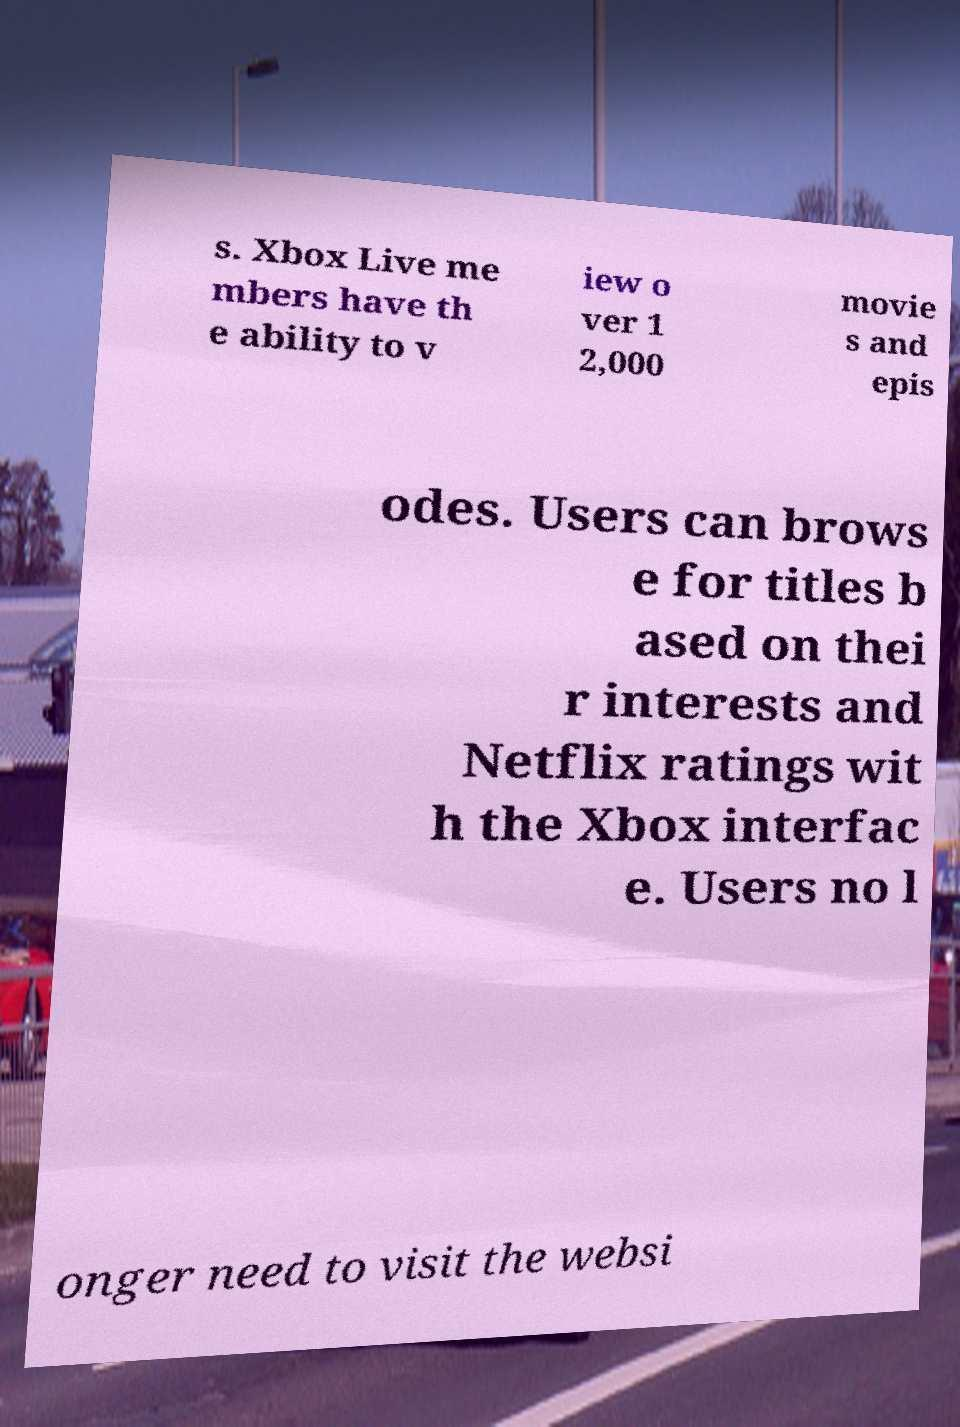Please identify and transcribe the text found in this image. s. Xbox Live me mbers have th e ability to v iew o ver 1 2,000 movie s and epis odes. Users can brows e for titles b ased on thei r interests and Netflix ratings wit h the Xbox interfac e. Users no l onger need to visit the websi 